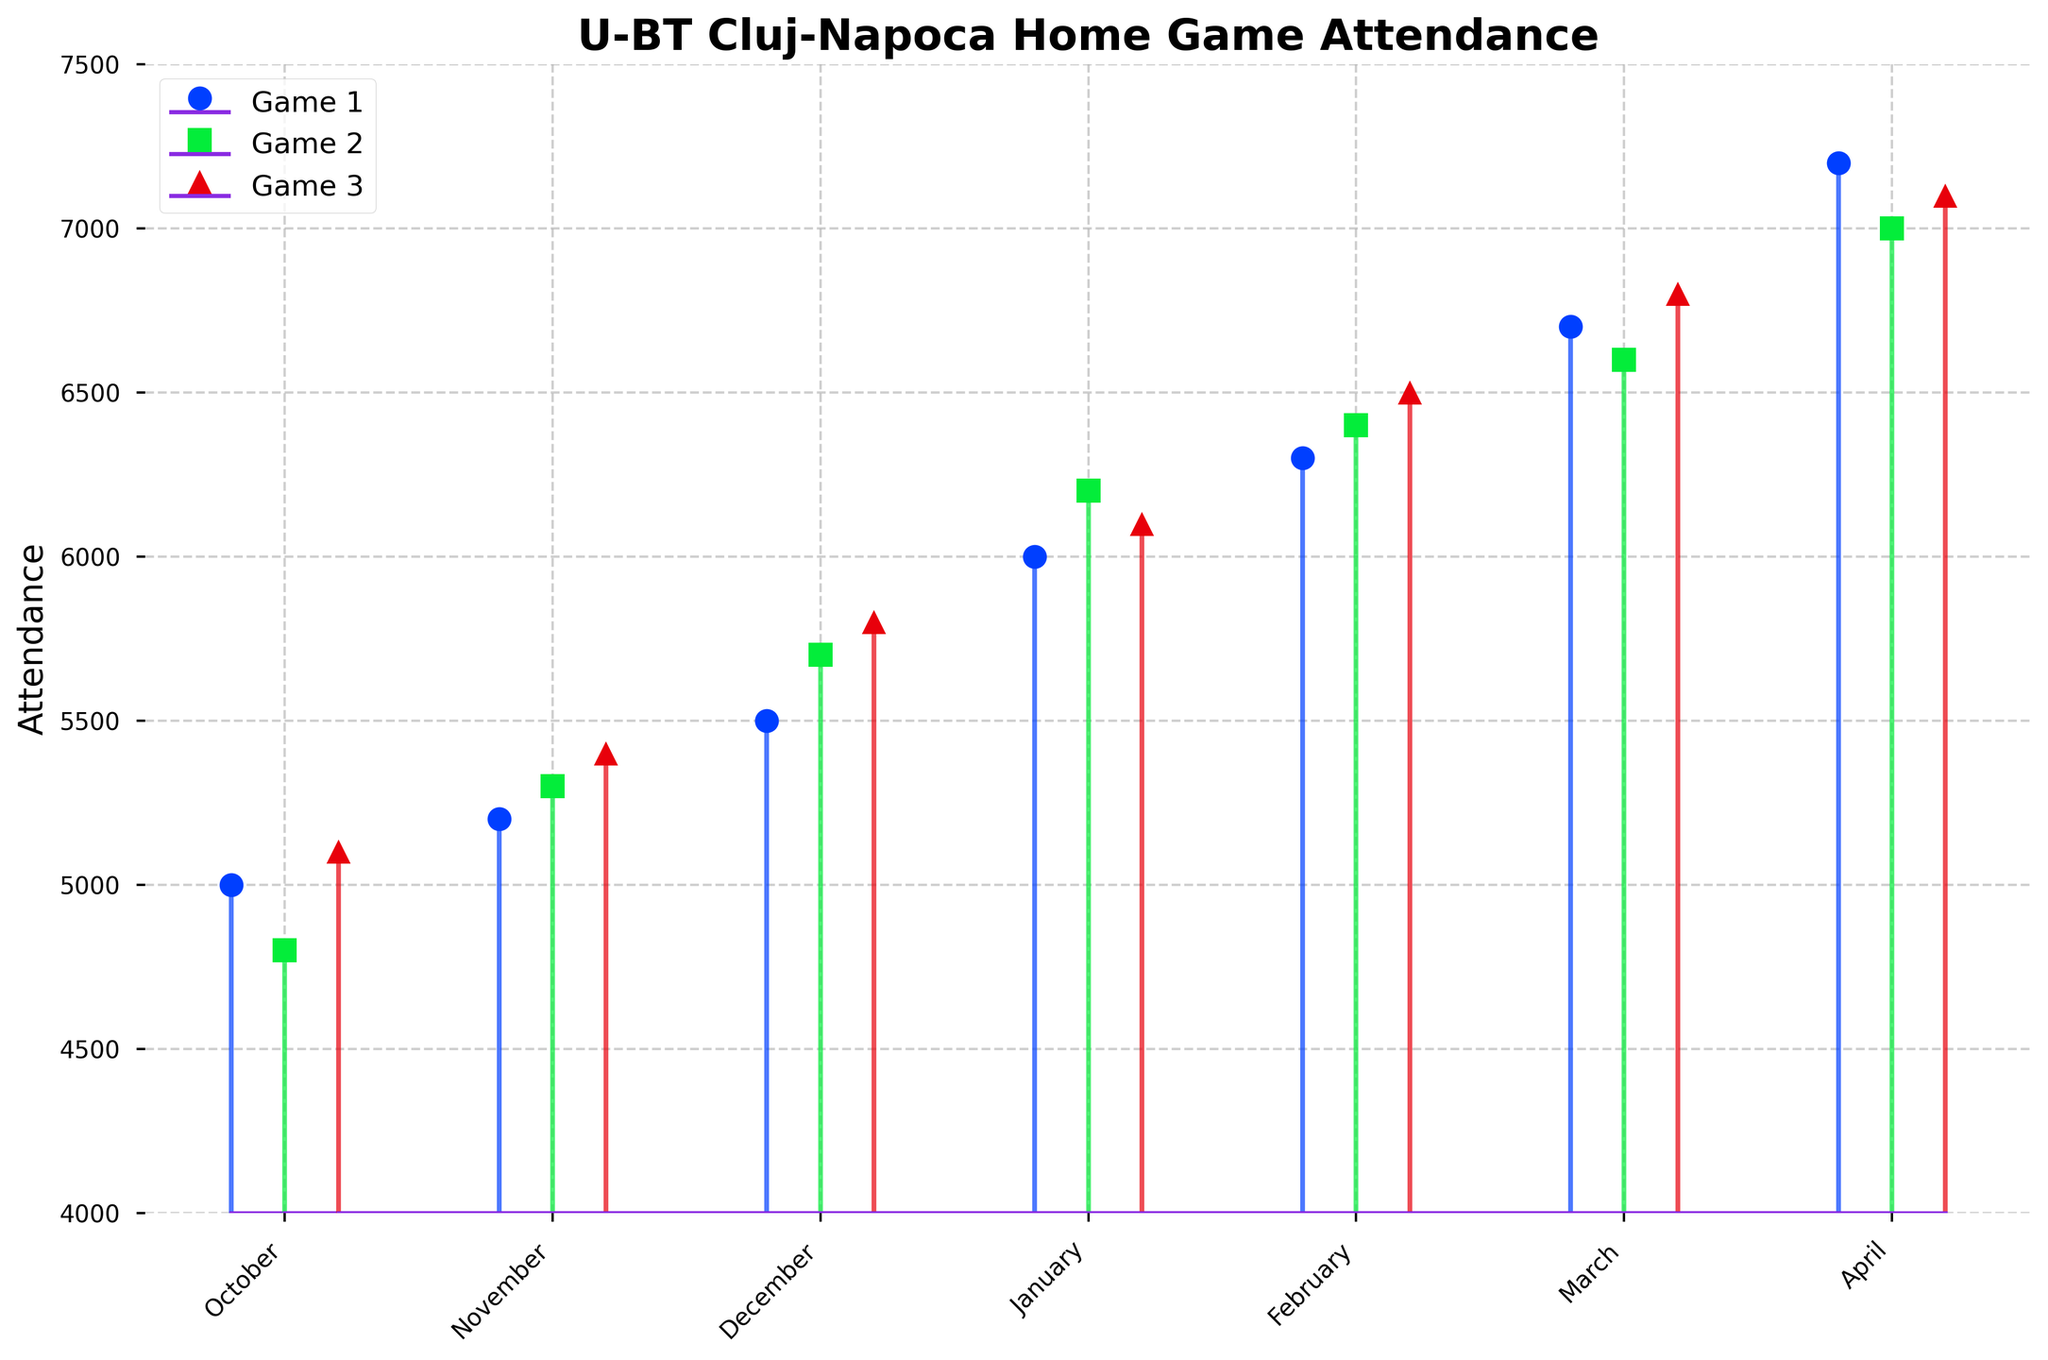What is the title of the plot? The title of the plot is typically found at the top of the figure, providing a summary of what the data represents. In this case, it indicates the content related to U-BT Cluj-Napoca's home game attendance.
Answer: U-BT Cluj-Napoca Home Game Attendance How many games are tracked each month? The plot uses different markers for three sets of data points in each month, representing the attendance of three games.
Answer: 3 Which month had the highest attendance for Game 1? To find this, look at the height of the marker line for Game 1 attendance in each month’s stem plot. The marker line's height represents the attendance.
Answer: April What is the range of attendance values in February? Identify the minimum and maximum points of attendance for February's Games 1, 2, and 3. Subtract the smallest attendance value from the largest for that month. The range is 6500 - 6300 = 200.
Answer: 200 What is the average attendance for Game 2 throughout the season? Add the attendance numbers for Game 2 across all months and divide by the number of months. For Game 2: (4800 + 5300 + 5700 + 6200 + 6400 + 6600 + 7000) / 7.
Answer: 6000 In which month did the attendance decline from Game 1 to Game 2 and then increase in Game 3? Check for each month if the attendance plotted for Game 2 is lower than Game 1 and higher for Game 3 than Game 2. Identify the correct pattern.
Answer: January What is the trend in attendance from October to April? Observe if the attendance values for the games increase, decrease, or fluctuate month by month. Consistently increasing values indicate an upward trend.
Answer: Increasing Which month had the lowest overall attendance across all three games? Sum the attendances for all three games for each month and identify the month with the smallest total. Compare sums (x1 + x2 + x3) for each month.
Answer: October How many months had at least one game with attendance above 7000? Count the months where any of the three markers (describing the attendance of each game) exceed the 7000 mark. Verify individually for each month.
Answer: 1 